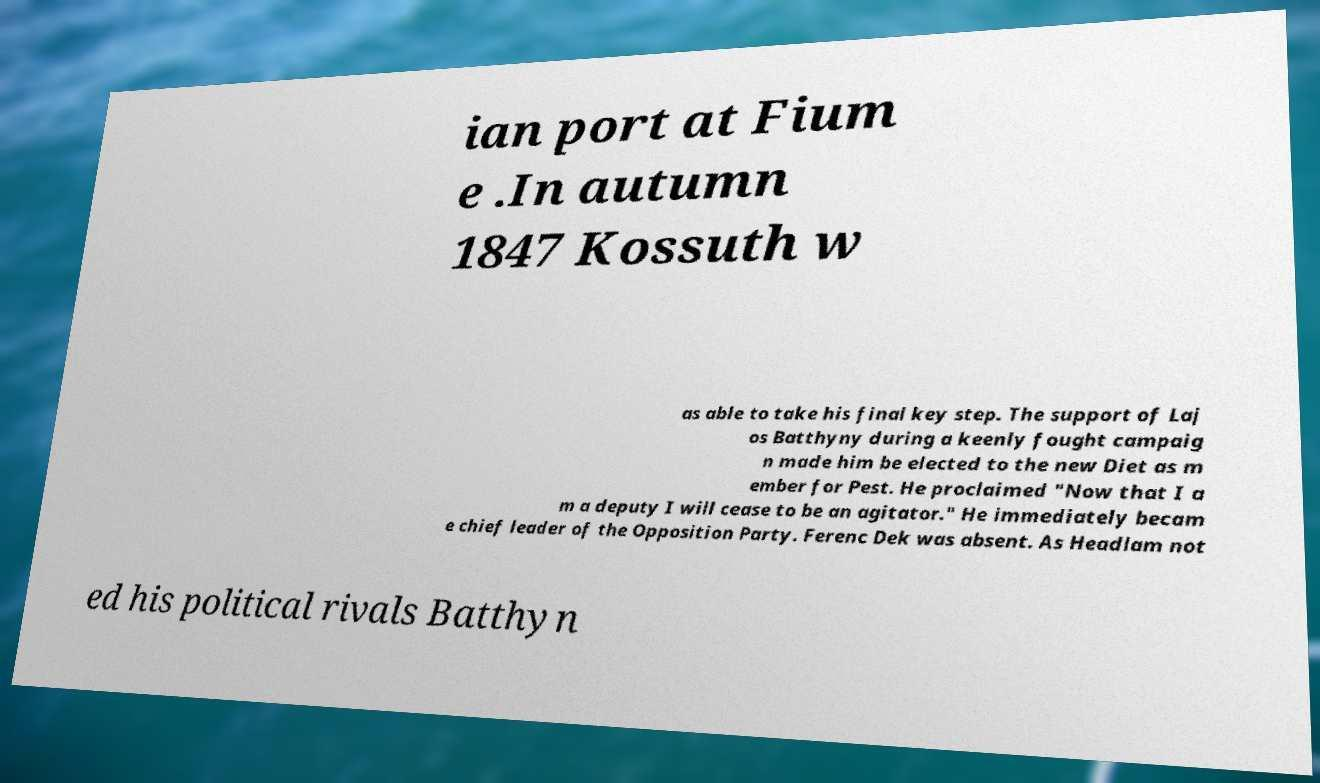There's text embedded in this image that I need extracted. Can you transcribe it verbatim? ian port at Fium e .In autumn 1847 Kossuth w as able to take his final key step. The support of Laj os Batthyny during a keenly fought campaig n made him be elected to the new Diet as m ember for Pest. He proclaimed "Now that I a m a deputy I will cease to be an agitator." He immediately becam e chief leader of the Opposition Party. Ferenc Dek was absent. As Headlam not ed his political rivals Batthyn 